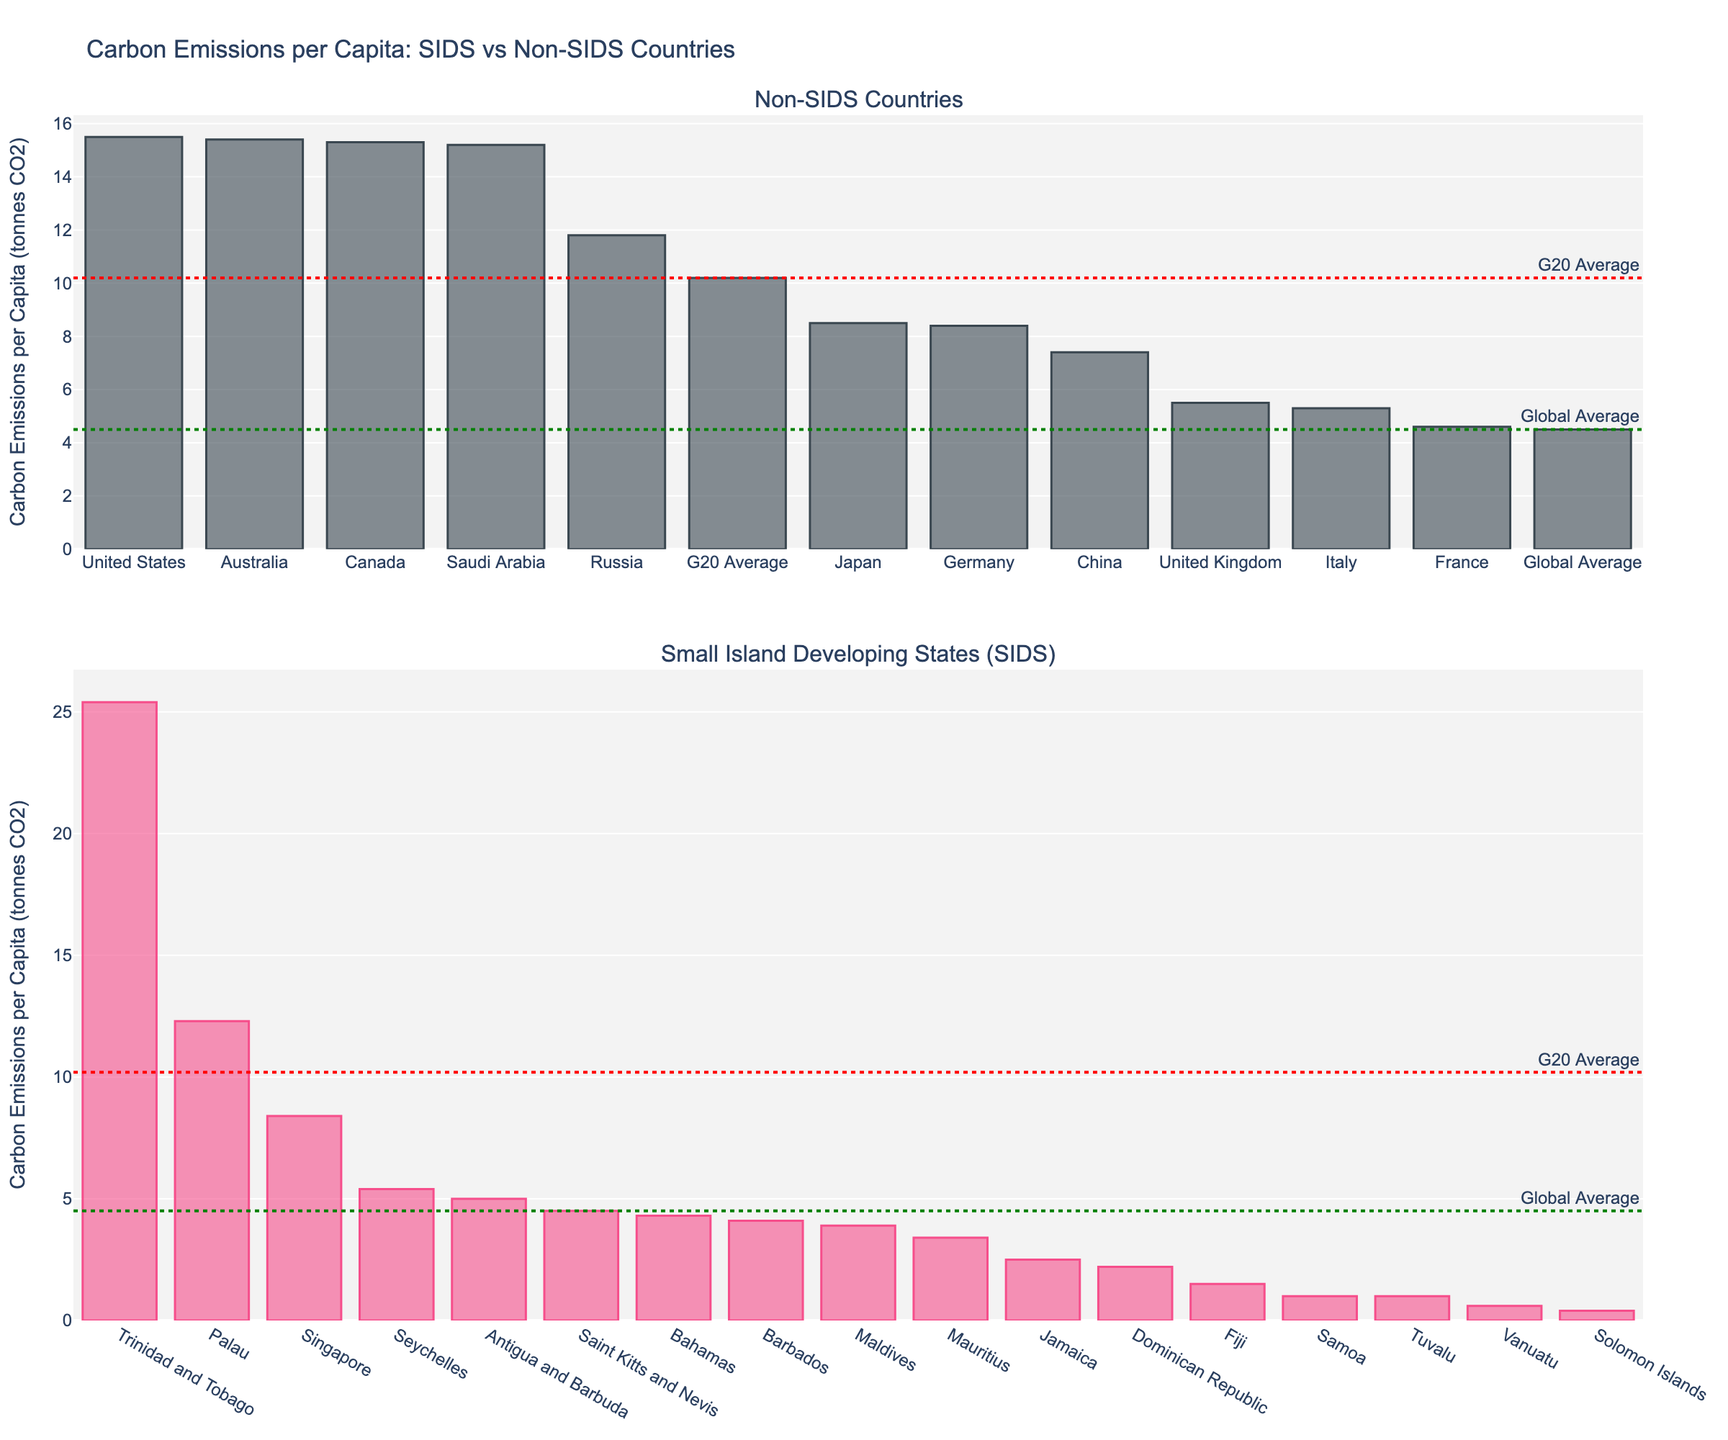Which country has the highest carbon emissions per capita among SIDS? By looking at the SIDS plot, Trinidad and Tobago has the tallest bar indicating the highest emissions per capita among SIDS.
Answer: Trinidad and Tobago How do the carbon emissions per capita for Fiji and Samoa compare? In the SIDS plot, we see that Fiji has higher emissions per capita (~1.5 tonnes CO2) compared to Samoa (~1.0 tonnes CO2).
Answer: Fiji has higher emissions What is the carbon emissions per capita difference between Saudi Arabia and France? In the non-SIDS plot, Saudi Arabia emits 15.2 tonnes CO2 per capita while France emits 4.6 tonnes. The difference is 15.2 - 4.6 = 10.6 tonnes CO2 per capita.
Answer: 10.6 tonnes CO2 Which SIDS has carbon emissions per capita closest to the global average? In the SIDS plot, Saint Kitts and Nevis, with emissions at 4.5 tonnes CO2, closely matches the global average indicated by the dotted line.
Answer: Saint Kitts and Nevis Is any SIDS emitting more carbon per capita than the G20 average? The G20 average line on the SIDS plot shows 10.2 tonnes CO2, and Trinidad and Tobago (25.4 tonnes) and Palau (12.3 tonnes) have higher emissions.
Answer: Trinidad and Tobago, Palau What is the average carbon emissions per capita for SIDS countries listed on the plot? Adding the emissions per capita for all SIDS and then dividing by the number of SIDS gives: (5.4 + 25.4 + 4.3 + 4.1 + 3.9 + 5.0 + 3.4 + 8.4 + 12.3 + 4.5 + 1.5 + 2.5 + 2.2 + 1.0 + 0.6 + 0.4 + 1.0)/17 = 5.41 tonnes CO2.
Answer: 5.41 tonnes CO2 How does the carbon emissions per capita for Germany compare to Singapore? Germany and Singapore have the same carbon emissions per capita of 8.4 tonnes CO2 as visible in both plots.
Answer: Equal Among the non-SIDS countries listed, which one has the lowest carbon emissions per capita? In the non-SIDS plot, Italy has the lowest emissions per capita of 5.3 tonnes CO2.
Answer: Italy What is the combined carbon emissions per capita for Japan and China? Japan has emissions of 8.5 tonnes CO2 and China has 7.4 tonnes CO2. Their combined emissions are 8.5 + 7.4 = 15.9 tonnes CO2.
Answer: 15.9 tonnes CO2 Between the Bahamas and Canada, which country has higher carbon emissions per capita? From the respective SIDS and non-SIDS plots, Canada emits 15.3 tonnes CO2 per capita, whereas Bahamas emits 4.3 tonnes CO2. Thus, Canada has higher emissions.
Answer: Canada 